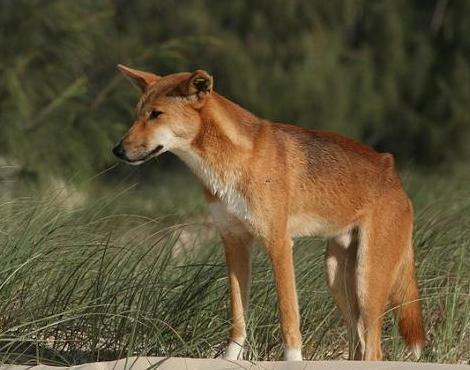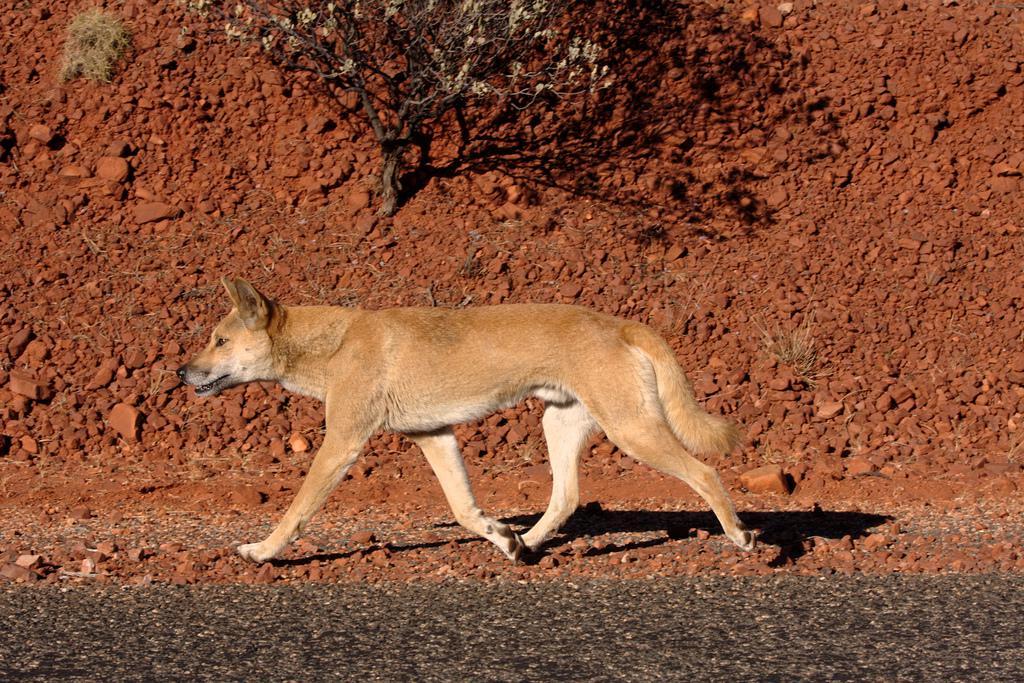The first image is the image on the left, the second image is the image on the right. Analyze the images presented: Is the assertion "The dingo on the right is laying on the grass." valid? Answer yes or no. No. The first image is the image on the left, the second image is the image on the right. Assess this claim about the two images: "There is a tan and white canine laying in the dirt and grass.". Correct or not? Answer yes or no. No. 